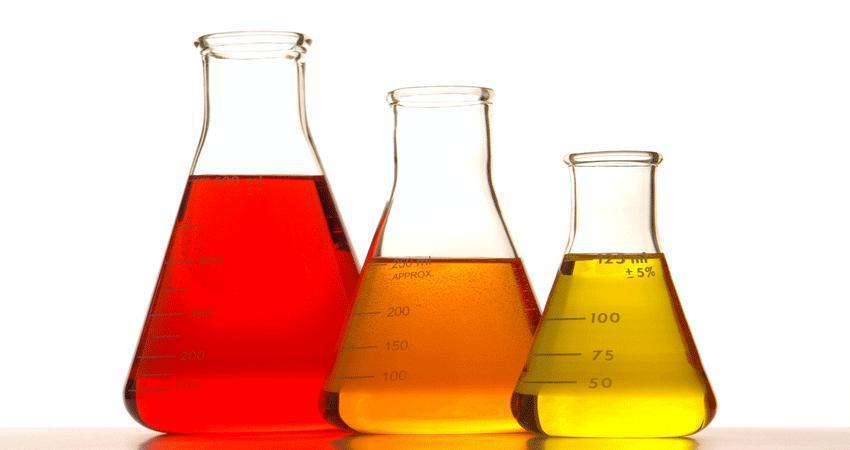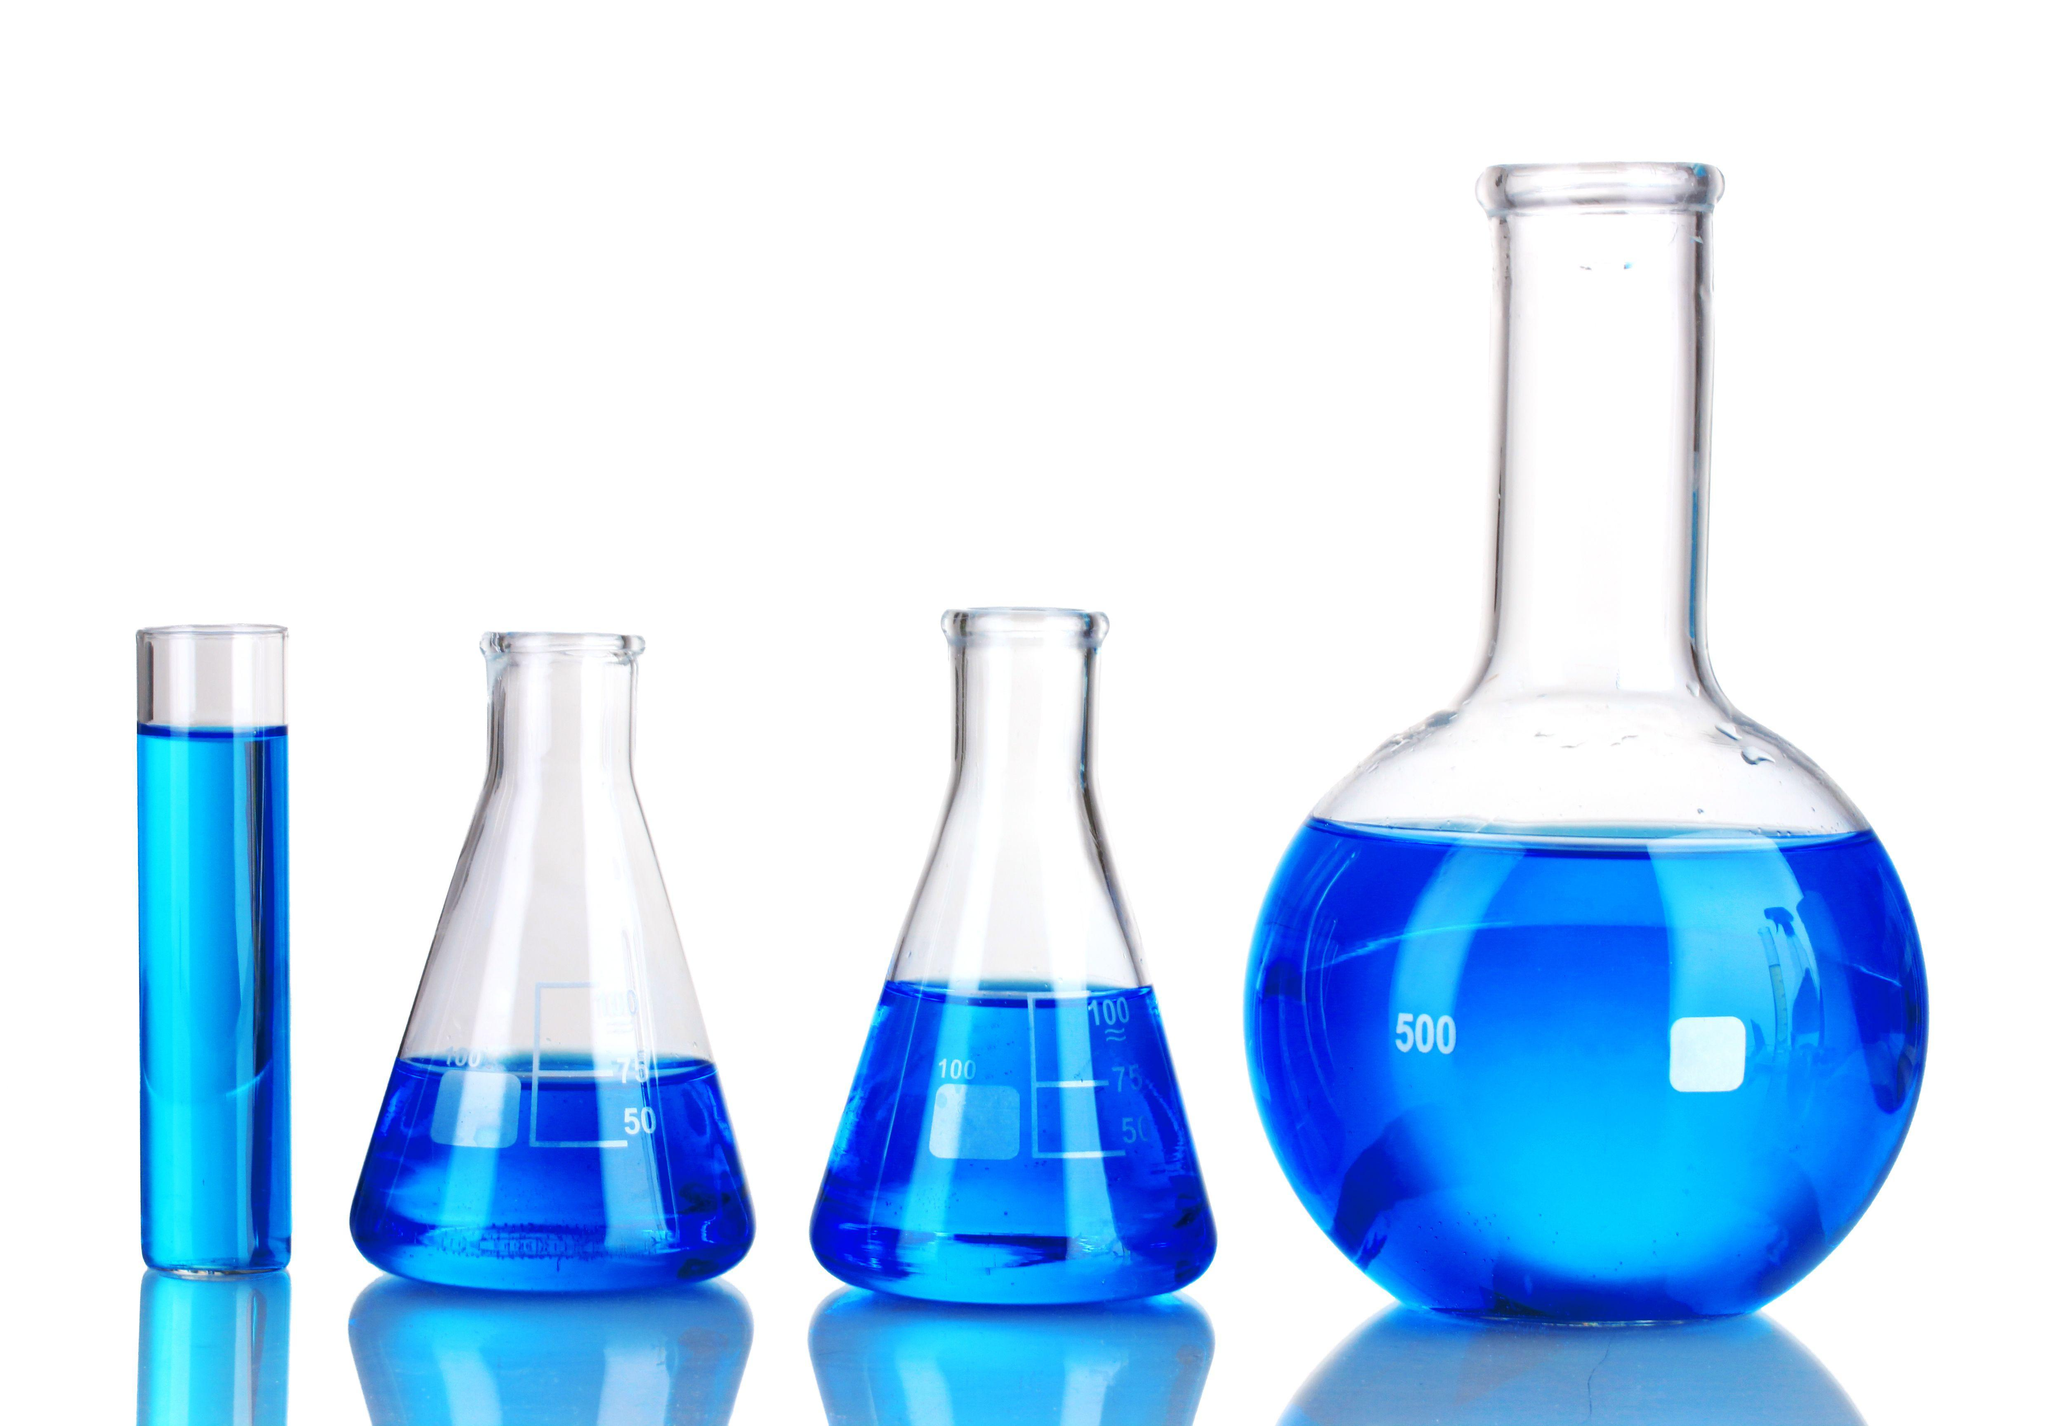The first image is the image on the left, the second image is the image on the right. Assess this claim about the two images: "One image shows a row of no more than five beakers displayed with their bases level, and each beaker contains a different color of liquid.". Correct or not? Answer yes or no. Yes. The first image is the image on the left, the second image is the image on the right. Analyze the images presented: Is the assertion "Every image shows at least four containers of colored liquid and there are at least four different colors of liquid in each photo." valid? Answer yes or no. No. 